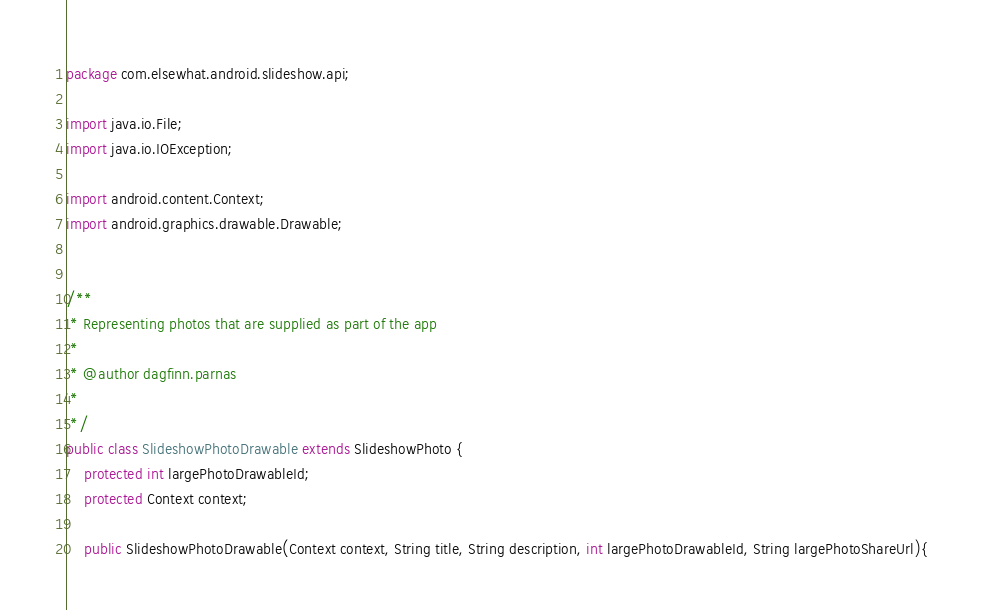<code> <loc_0><loc_0><loc_500><loc_500><_Java_>package com.elsewhat.android.slideshow.api;

import java.io.File;
import java.io.IOException;

import android.content.Context;
import android.graphics.drawable.Drawable;


/**
 * Representing photos that are supplied as part of the app
 * 
 * @author dagfinn.parnas
 *
 */
public class SlideshowPhotoDrawable extends SlideshowPhoto {
	protected int largePhotoDrawableId;
	protected Context context;
	
	public SlideshowPhotoDrawable(Context context, String title, String description, int largePhotoDrawableId, String largePhotoShareUrl){</code> 